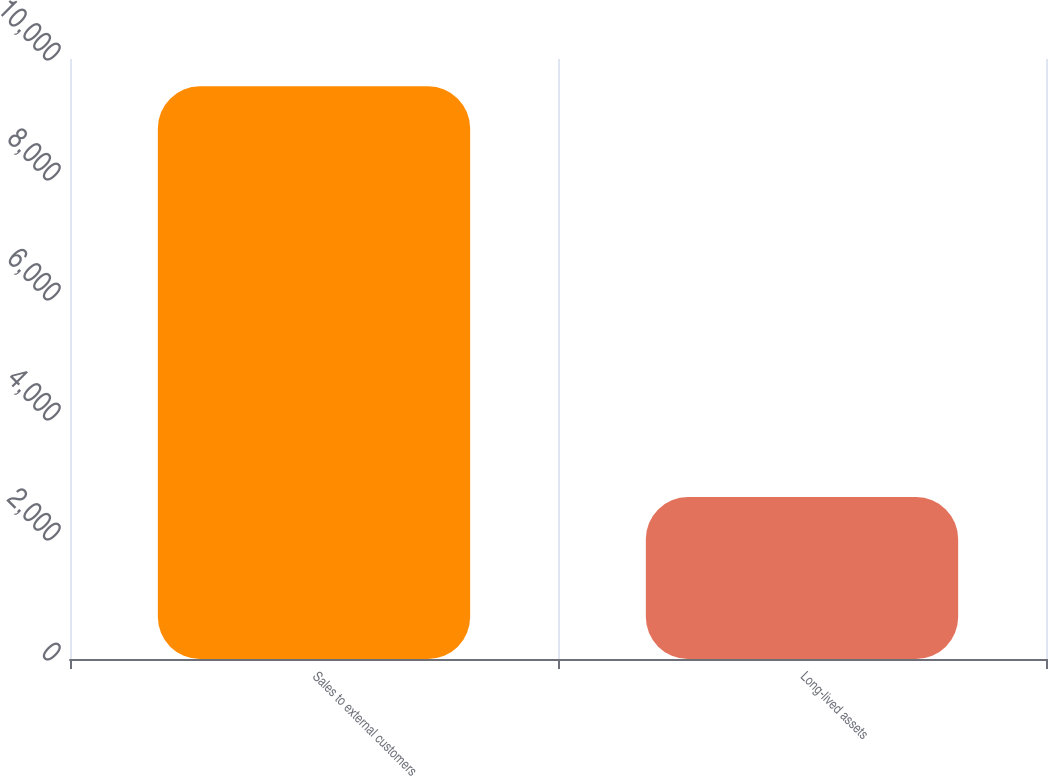Convert chart. <chart><loc_0><loc_0><loc_500><loc_500><bar_chart><fcel>Sales to external customers<fcel>Long-lived assets<nl><fcel>9544<fcel>2698<nl></chart> 